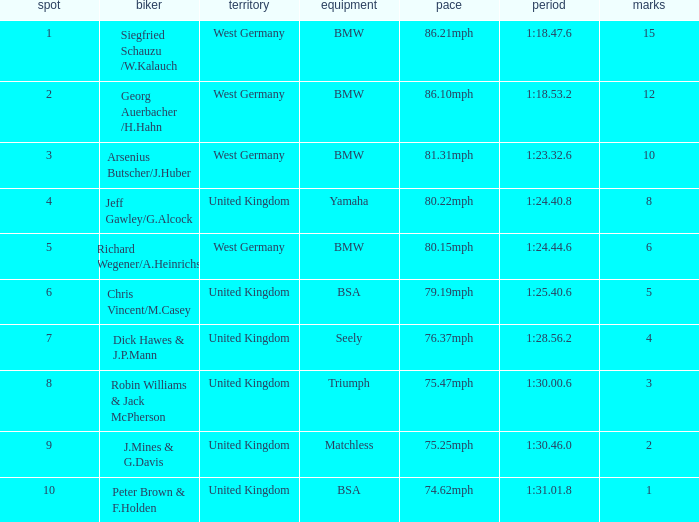Which place has points larger than 1, a bmw machine, and a time of 1:18.47.6? 1.0. 